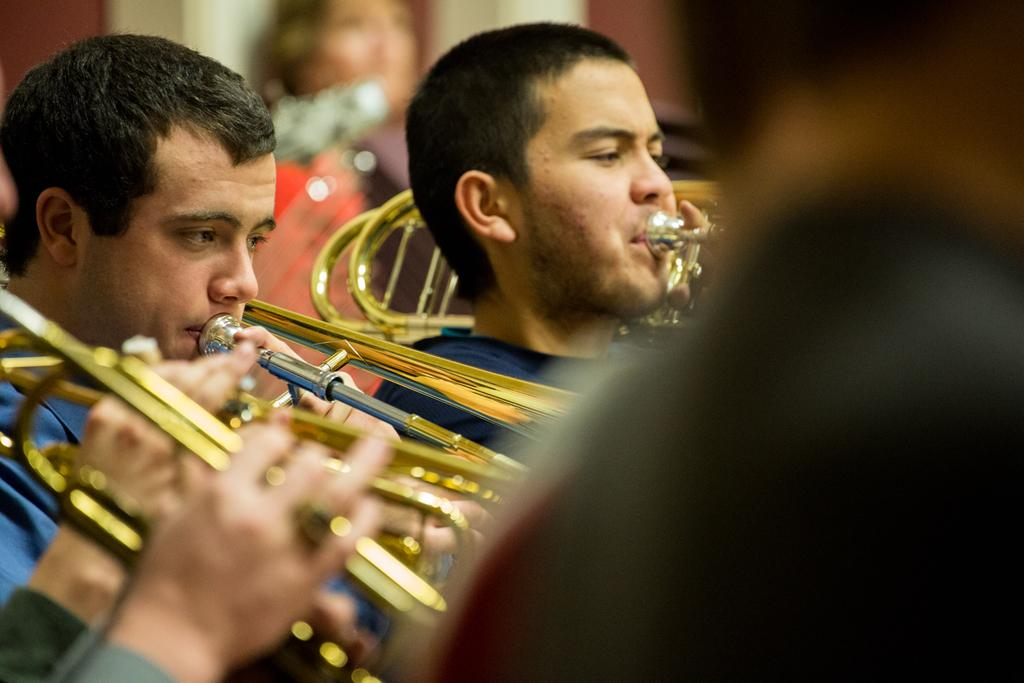How many people are present in the image? There are many people in the image. What are the people wearing? The people are wearing clothes. What else can be seen in the image besides people? There are musical instruments in the image. Can you describe the visual quality of the right side and background of the image? The right side and background of the image are blurred. What emotions are the people expressing in the image? The provided facts do not mention any specific emotions being expressed by the people in the image. --- 